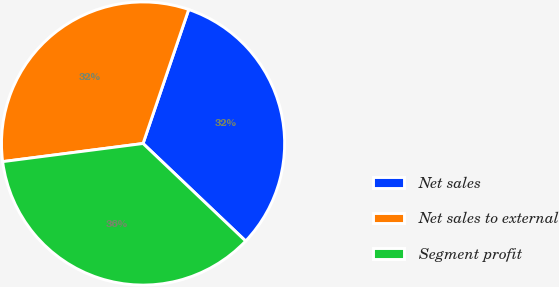Convert chart to OTSL. <chart><loc_0><loc_0><loc_500><loc_500><pie_chart><fcel>Net sales<fcel>Net sales to external<fcel>Segment profit<nl><fcel>31.87%<fcel>32.27%<fcel>35.86%<nl></chart> 